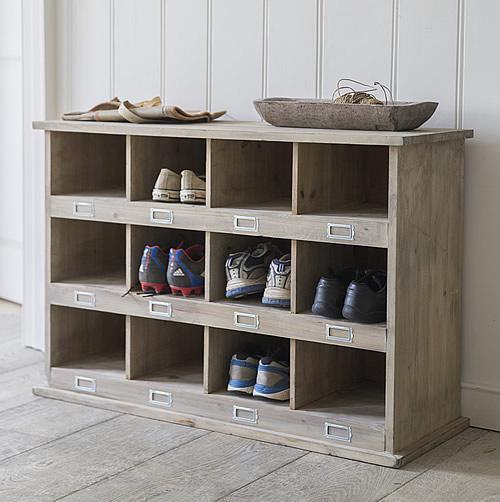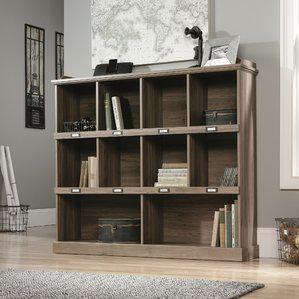The first image is the image on the left, the second image is the image on the right. Examine the images to the left and right. Is the description "Exactly one image contains potted flowers." accurate? Answer yes or no. No. 